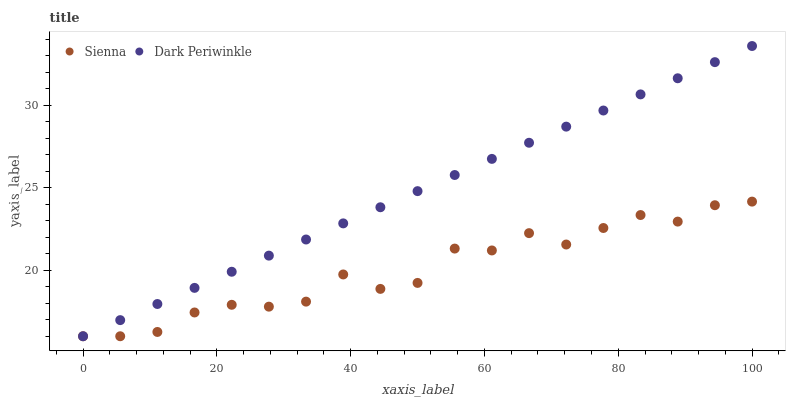Does Sienna have the minimum area under the curve?
Answer yes or no. Yes. Does Dark Periwinkle have the maximum area under the curve?
Answer yes or no. Yes. Does Dark Periwinkle have the minimum area under the curve?
Answer yes or no. No. Is Dark Periwinkle the smoothest?
Answer yes or no. Yes. Is Sienna the roughest?
Answer yes or no. Yes. Is Dark Periwinkle the roughest?
Answer yes or no. No. Does Sienna have the lowest value?
Answer yes or no. Yes. Does Dark Periwinkle have the highest value?
Answer yes or no. Yes. Does Dark Periwinkle intersect Sienna?
Answer yes or no. Yes. Is Dark Periwinkle less than Sienna?
Answer yes or no. No. Is Dark Periwinkle greater than Sienna?
Answer yes or no. No. 